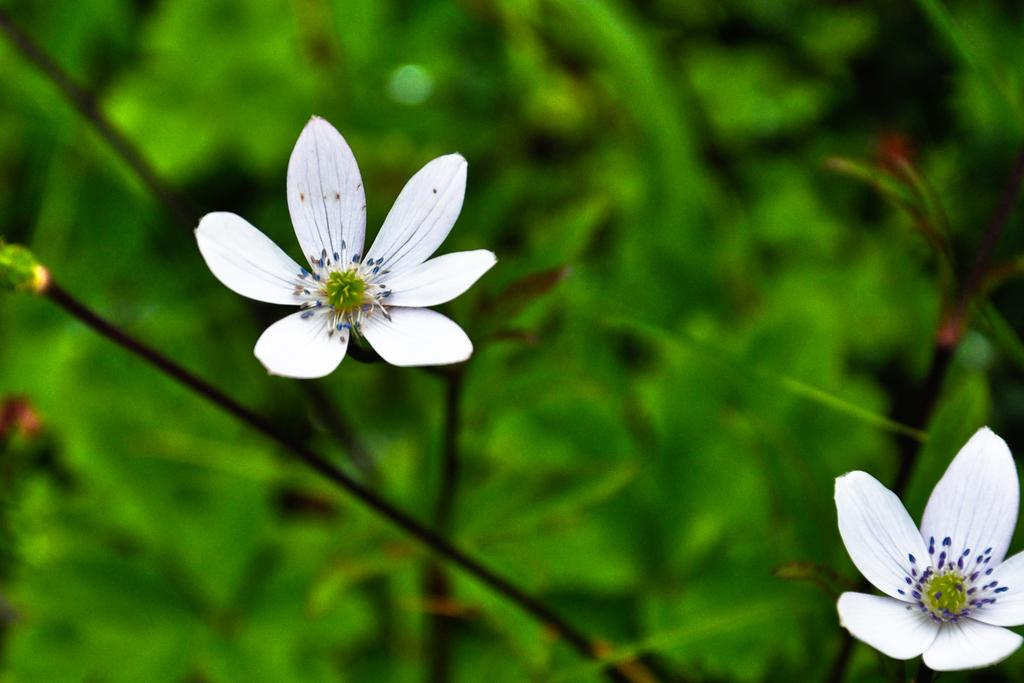What is located in the foreground of the picture? There are flowers and stems in the foreground of the picture. Can you describe the flowers in the foreground? The flowers are not specifically described in the facts, but they are present in the foreground. What can be seen in the background of the picture? There is greenery in the background of the picture. What type of hat is being worn by the plantation owner in the image? There is no plantation or plantation owner present in the image; it features flowers and greenery. What is the surprise element in the image? There is no surprise element mentioned in the facts, and the image does not depict any surprises. 